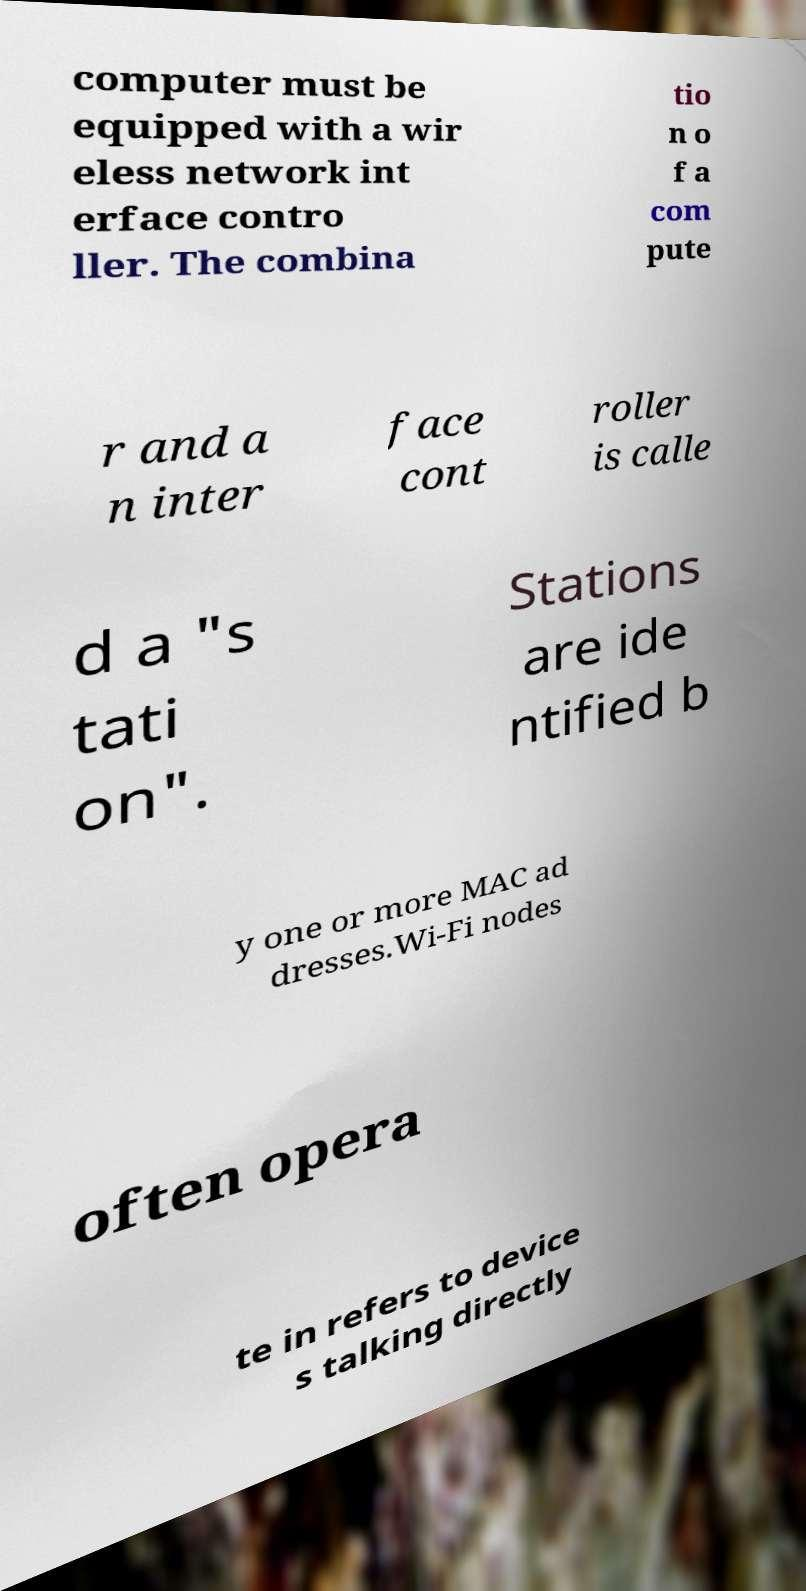For documentation purposes, I need the text within this image transcribed. Could you provide that? computer must be equipped with a wir eless network int erface contro ller. The combina tio n o f a com pute r and a n inter face cont roller is calle d a "s tati on". Stations are ide ntified b y one or more MAC ad dresses.Wi-Fi nodes often opera te in refers to device s talking directly 